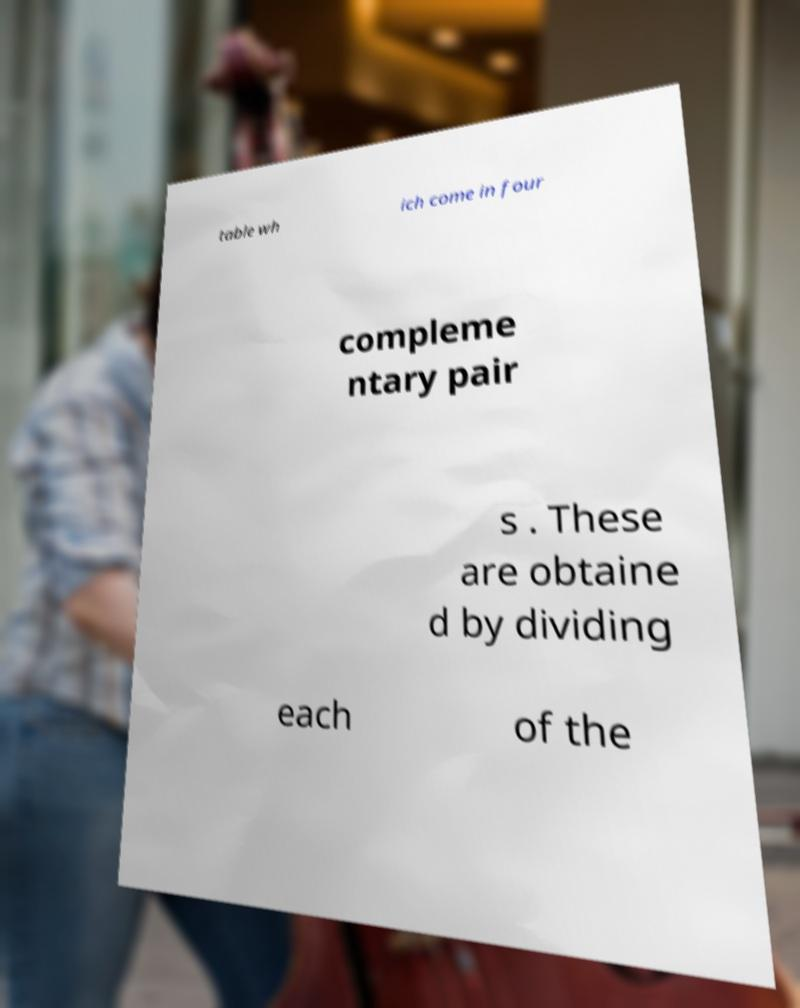What messages or text are displayed in this image? I need them in a readable, typed format. table wh ich come in four compleme ntary pair s . These are obtaine d by dividing each of the 